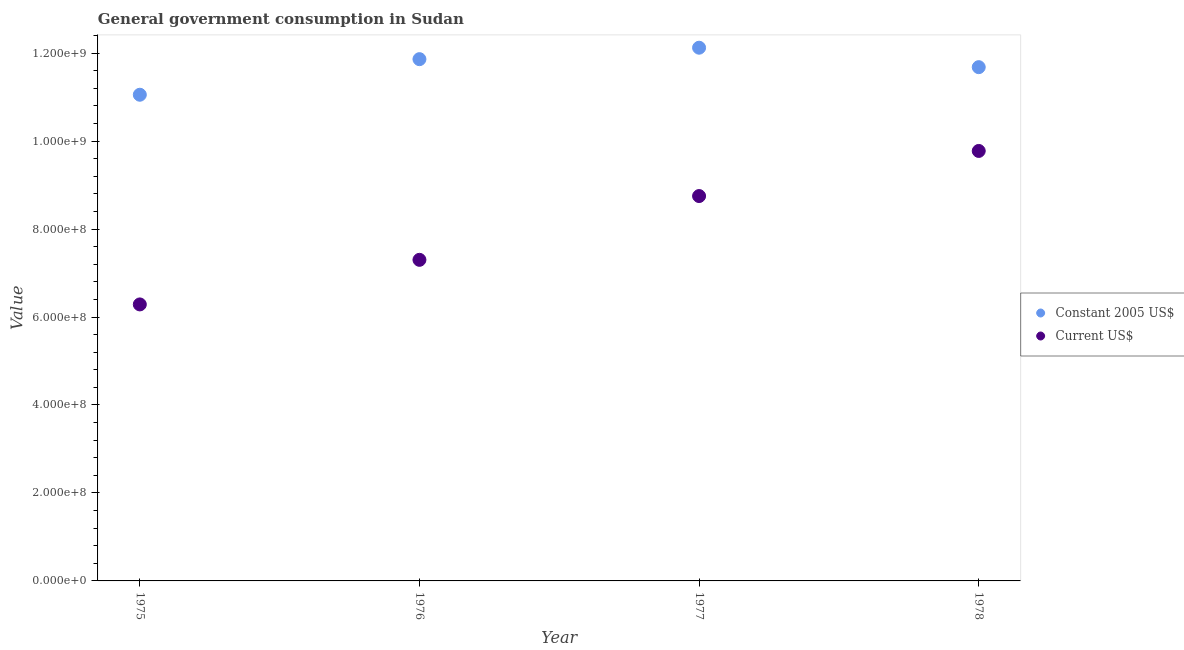Is the number of dotlines equal to the number of legend labels?
Make the answer very short. Yes. What is the value consumed in constant 2005 us$ in 1977?
Offer a very short reply. 1.21e+09. Across all years, what is the maximum value consumed in constant 2005 us$?
Ensure brevity in your answer.  1.21e+09. Across all years, what is the minimum value consumed in current us$?
Offer a terse response. 6.29e+08. In which year was the value consumed in constant 2005 us$ maximum?
Your answer should be compact. 1977. In which year was the value consumed in current us$ minimum?
Keep it short and to the point. 1975. What is the total value consumed in current us$ in the graph?
Give a very brief answer. 3.21e+09. What is the difference between the value consumed in constant 2005 us$ in 1977 and that in 1978?
Give a very brief answer. 4.42e+07. What is the difference between the value consumed in current us$ in 1975 and the value consumed in constant 2005 us$ in 1978?
Make the answer very short. -5.39e+08. What is the average value consumed in constant 2005 us$ per year?
Keep it short and to the point. 1.17e+09. In the year 1976, what is the difference between the value consumed in constant 2005 us$ and value consumed in current us$?
Give a very brief answer. 4.56e+08. What is the ratio of the value consumed in constant 2005 us$ in 1975 to that in 1977?
Your answer should be very brief. 0.91. Is the value consumed in current us$ in 1975 less than that in 1977?
Your answer should be very brief. Yes. What is the difference between the highest and the second highest value consumed in constant 2005 us$?
Offer a terse response. 2.60e+07. What is the difference between the highest and the lowest value consumed in current us$?
Offer a very short reply. 3.49e+08. Does the value consumed in current us$ monotonically increase over the years?
Keep it short and to the point. Yes. Does the graph contain any zero values?
Ensure brevity in your answer.  No. Does the graph contain grids?
Offer a terse response. No. How many legend labels are there?
Offer a very short reply. 2. How are the legend labels stacked?
Provide a short and direct response. Vertical. What is the title of the graph?
Ensure brevity in your answer.  General government consumption in Sudan. What is the label or title of the Y-axis?
Provide a short and direct response. Value. What is the Value in Constant 2005 US$ in 1975?
Ensure brevity in your answer.  1.11e+09. What is the Value in Current US$ in 1975?
Ensure brevity in your answer.  6.29e+08. What is the Value in Constant 2005 US$ in 1976?
Provide a short and direct response. 1.19e+09. What is the Value of Current US$ in 1976?
Give a very brief answer. 7.30e+08. What is the Value of Constant 2005 US$ in 1977?
Offer a very short reply. 1.21e+09. What is the Value in Current US$ in 1977?
Offer a very short reply. 8.75e+08. What is the Value of Constant 2005 US$ in 1978?
Keep it short and to the point. 1.17e+09. What is the Value in Current US$ in 1978?
Offer a terse response. 9.78e+08. Across all years, what is the maximum Value of Constant 2005 US$?
Keep it short and to the point. 1.21e+09. Across all years, what is the maximum Value of Current US$?
Provide a short and direct response. 9.78e+08. Across all years, what is the minimum Value of Constant 2005 US$?
Your response must be concise. 1.11e+09. Across all years, what is the minimum Value of Current US$?
Keep it short and to the point. 6.29e+08. What is the total Value in Constant 2005 US$ in the graph?
Your response must be concise. 4.67e+09. What is the total Value in Current US$ in the graph?
Give a very brief answer. 3.21e+09. What is the difference between the Value of Constant 2005 US$ in 1975 and that in 1976?
Give a very brief answer. -8.09e+07. What is the difference between the Value in Current US$ in 1975 and that in 1976?
Your response must be concise. -1.01e+08. What is the difference between the Value in Constant 2005 US$ in 1975 and that in 1977?
Make the answer very short. -1.07e+08. What is the difference between the Value of Current US$ in 1975 and that in 1977?
Your answer should be compact. -2.46e+08. What is the difference between the Value in Constant 2005 US$ in 1975 and that in 1978?
Ensure brevity in your answer.  -6.27e+07. What is the difference between the Value in Current US$ in 1975 and that in 1978?
Ensure brevity in your answer.  -3.49e+08. What is the difference between the Value of Constant 2005 US$ in 1976 and that in 1977?
Your answer should be compact. -2.60e+07. What is the difference between the Value of Current US$ in 1976 and that in 1977?
Your response must be concise. -1.45e+08. What is the difference between the Value of Constant 2005 US$ in 1976 and that in 1978?
Offer a terse response. 1.82e+07. What is the difference between the Value of Current US$ in 1976 and that in 1978?
Ensure brevity in your answer.  -2.48e+08. What is the difference between the Value in Constant 2005 US$ in 1977 and that in 1978?
Offer a terse response. 4.42e+07. What is the difference between the Value in Current US$ in 1977 and that in 1978?
Your answer should be compact. -1.03e+08. What is the difference between the Value of Constant 2005 US$ in 1975 and the Value of Current US$ in 1976?
Give a very brief answer. 3.75e+08. What is the difference between the Value of Constant 2005 US$ in 1975 and the Value of Current US$ in 1977?
Your response must be concise. 2.30e+08. What is the difference between the Value in Constant 2005 US$ in 1975 and the Value in Current US$ in 1978?
Keep it short and to the point. 1.28e+08. What is the difference between the Value of Constant 2005 US$ in 1976 and the Value of Current US$ in 1977?
Provide a short and direct response. 3.11e+08. What is the difference between the Value of Constant 2005 US$ in 1976 and the Value of Current US$ in 1978?
Your answer should be very brief. 2.09e+08. What is the difference between the Value of Constant 2005 US$ in 1977 and the Value of Current US$ in 1978?
Offer a very short reply. 2.35e+08. What is the average Value of Constant 2005 US$ per year?
Keep it short and to the point. 1.17e+09. What is the average Value of Current US$ per year?
Your answer should be compact. 8.03e+08. In the year 1975, what is the difference between the Value of Constant 2005 US$ and Value of Current US$?
Your answer should be compact. 4.77e+08. In the year 1976, what is the difference between the Value of Constant 2005 US$ and Value of Current US$?
Ensure brevity in your answer.  4.56e+08. In the year 1977, what is the difference between the Value of Constant 2005 US$ and Value of Current US$?
Offer a terse response. 3.37e+08. In the year 1978, what is the difference between the Value in Constant 2005 US$ and Value in Current US$?
Your answer should be compact. 1.90e+08. What is the ratio of the Value of Constant 2005 US$ in 1975 to that in 1976?
Your answer should be compact. 0.93. What is the ratio of the Value in Current US$ in 1975 to that in 1976?
Ensure brevity in your answer.  0.86. What is the ratio of the Value in Constant 2005 US$ in 1975 to that in 1977?
Your response must be concise. 0.91. What is the ratio of the Value of Current US$ in 1975 to that in 1977?
Provide a short and direct response. 0.72. What is the ratio of the Value of Constant 2005 US$ in 1975 to that in 1978?
Provide a short and direct response. 0.95. What is the ratio of the Value of Current US$ in 1975 to that in 1978?
Give a very brief answer. 0.64. What is the ratio of the Value in Constant 2005 US$ in 1976 to that in 1977?
Your answer should be compact. 0.98. What is the ratio of the Value of Current US$ in 1976 to that in 1977?
Offer a very short reply. 0.83. What is the ratio of the Value in Constant 2005 US$ in 1976 to that in 1978?
Make the answer very short. 1.02. What is the ratio of the Value in Current US$ in 1976 to that in 1978?
Make the answer very short. 0.75. What is the ratio of the Value of Constant 2005 US$ in 1977 to that in 1978?
Provide a succinct answer. 1.04. What is the ratio of the Value of Current US$ in 1977 to that in 1978?
Ensure brevity in your answer.  0.9. What is the difference between the highest and the second highest Value of Constant 2005 US$?
Your response must be concise. 2.60e+07. What is the difference between the highest and the second highest Value of Current US$?
Ensure brevity in your answer.  1.03e+08. What is the difference between the highest and the lowest Value of Constant 2005 US$?
Provide a succinct answer. 1.07e+08. What is the difference between the highest and the lowest Value in Current US$?
Provide a succinct answer. 3.49e+08. 